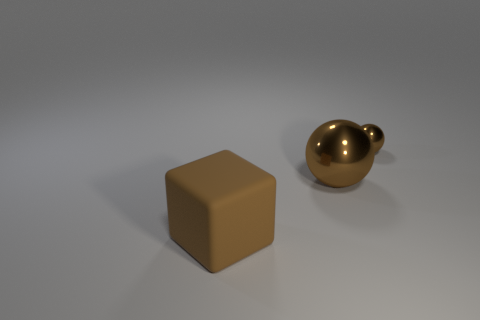What is the size of the brown matte cube?
Ensure brevity in your answer.  Large. Is there a big sphere made of the same material as the tiny object?
Keep it short and to the point. Yes. What size is the other brown shiny thing that is the same shape as the tiny shiny object?
Your answer should be compact. Large. Are there the same number of large things on the left side of the large brown matte cube and tiny red metallic objects?
Provide a short and direct response. Yes. There is a large brown thing that is to the right of the big cube; does it have the same shape as the tiny brown thing?
Provide a short and direct response. Yes. What shape is the tiny brown object?
Your answer should be very brief. Sphere. There is a big object that is to the right of the large brown thing in front of the large object right of the block; what is it made of?
Provide a short and direct response. Metal. What material is the cube that is the same color as the tiny ball?
Provide a short and direct response. Rubber. What number of things are either rubber blocks or balls?
Offer a terse response. 3. Does the big object that is to the right of the big rubber block have the same material as the cube?
Offer a terse response. No. 